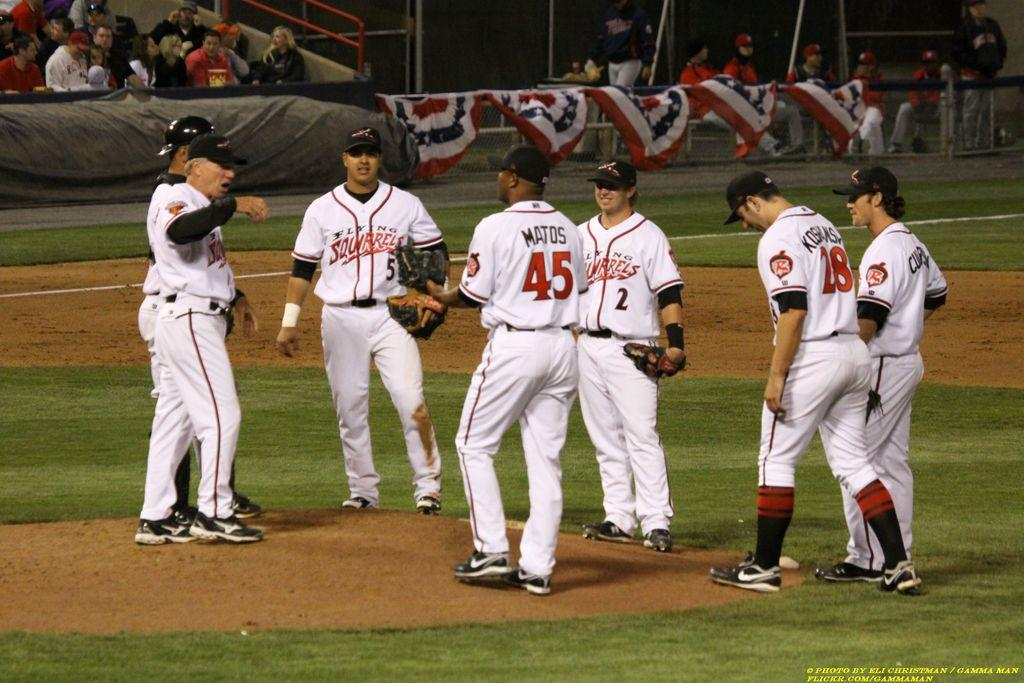<image>
Present a compact description of the photo's key features. Player number 5 for the Flying Squirrels stands with his teammates on the pitchers mound 